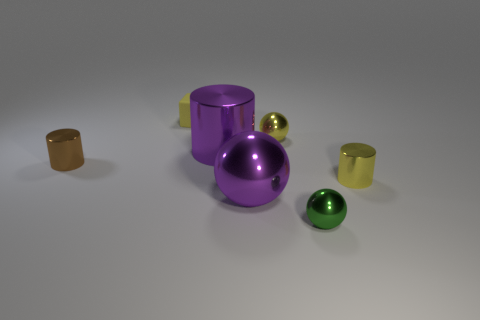Subtract 1 spheres. How many spheres are left? 2 Subtract all small metallic cylinders. How many cylinders are left? 1 Subtract all spheres. How many objects are left? 4 Add 3 brown metal blocks. How many objects exist? 10 Subtract all cyan balls. Subtract all gray cylinders. How many balls are left? 3 Subtract 0 cyan cubes. How many objects are left? 7 Subtract all rubber objects. Subtract all yellow balls. How many objects are left? 5 Add 5 tiny metallic things. How many tiny metallic things are left? 9 Add 7 tiny spheres. How many tiny spheres exist? 9 